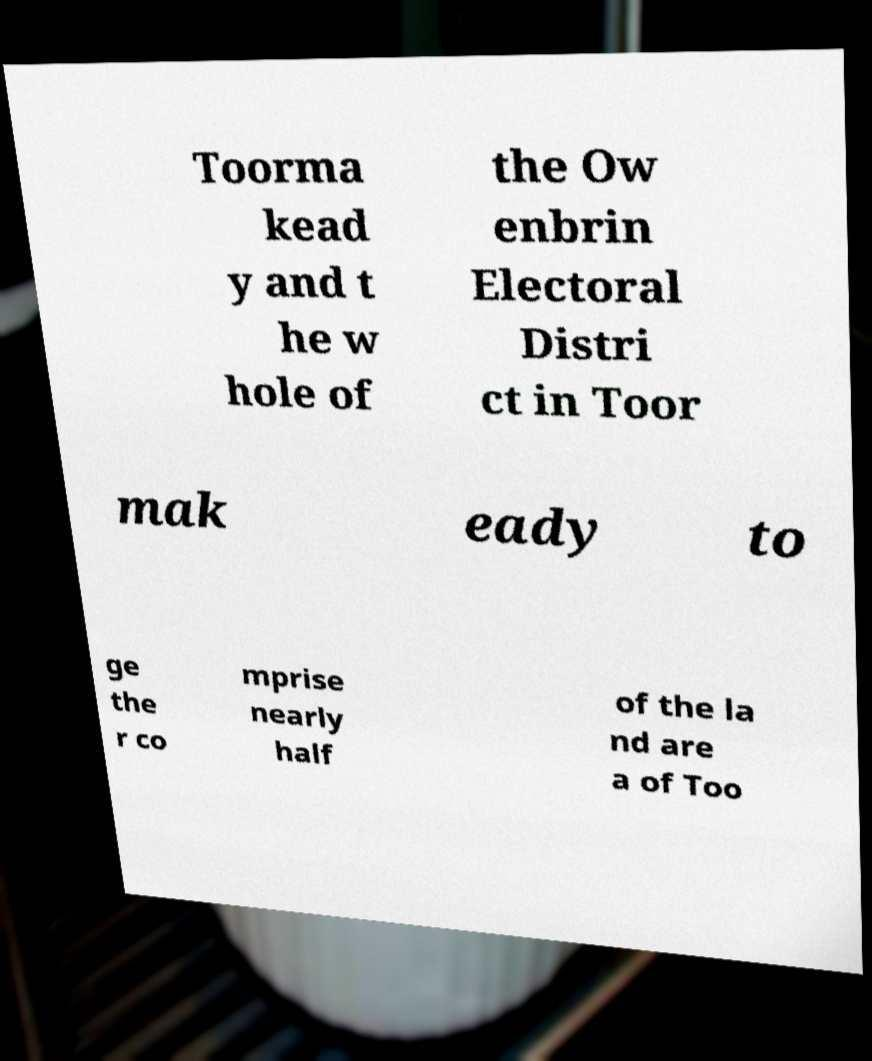Please read and relay the text visible in this image. What does it say? Toorma kead y and t he w hole of the Ow enbrin Electoral Distri ct in Toor mak eady to ge the r co mprise nearly half of the la nd are a of Too 